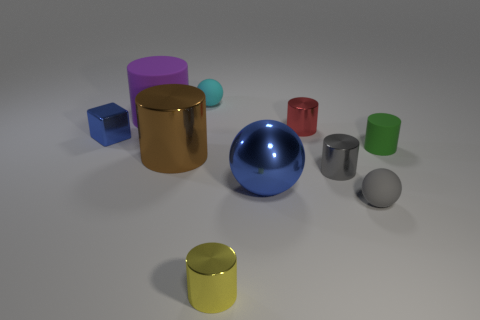The large object that is the same color as the tiny cube is what shape?
Provide a short and direct response. Sphere. Do the tiny shiny cube and the big thing that is on the right side of the yellow metallic cylinder have the same color?
Offer a very short reply. Yes. What is the size of the shiny ball that is the same color as the small block?
Keep it short and to the point. Large. What size is the purple rubber object that is the same shape as the brown object?
Your answer should be very brief. Large. Do the red object and the rubber cylinder that is on the left side of the big metal sphere have the same size?
Give a very brief answer. No. What is the small yellow cylinder made of?
Keep it short and to the point. Metal. What material is the green object that is the same size as the red shiny cylinder?
Offer a terse response. Rubber. Does the sphere that is behind the tiny green cylinder have the same material as the gray object that is in front of the blue shiny sphere?
Give a very brief answer. Yes. There is a yellow object that is the same size as the metallic block; what is its shape?
Ensure brevity in your answer.  Cylinder. How many other things are there of the same color as the small metallic block?
Your answer should be very brief. 1. 